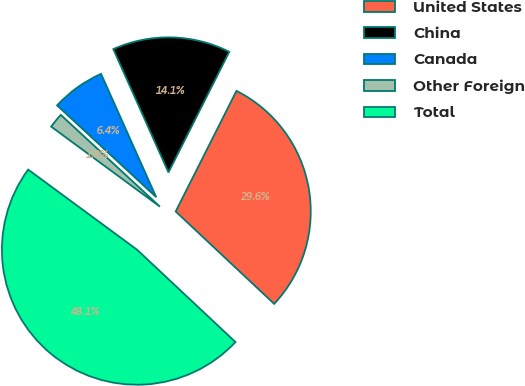Convert chart. <chart><loc_0><loc_0><loc_500><loc_500><pie_chart><fcel>United States<fcel>China<fcel>Canada<fcel>Other Foreign<fcel>Total<nl><fcel>29.56%<fcel>14.13%<fcel>6.42%<fcel>1.79%<fcel>48.11%<nl></chart> 